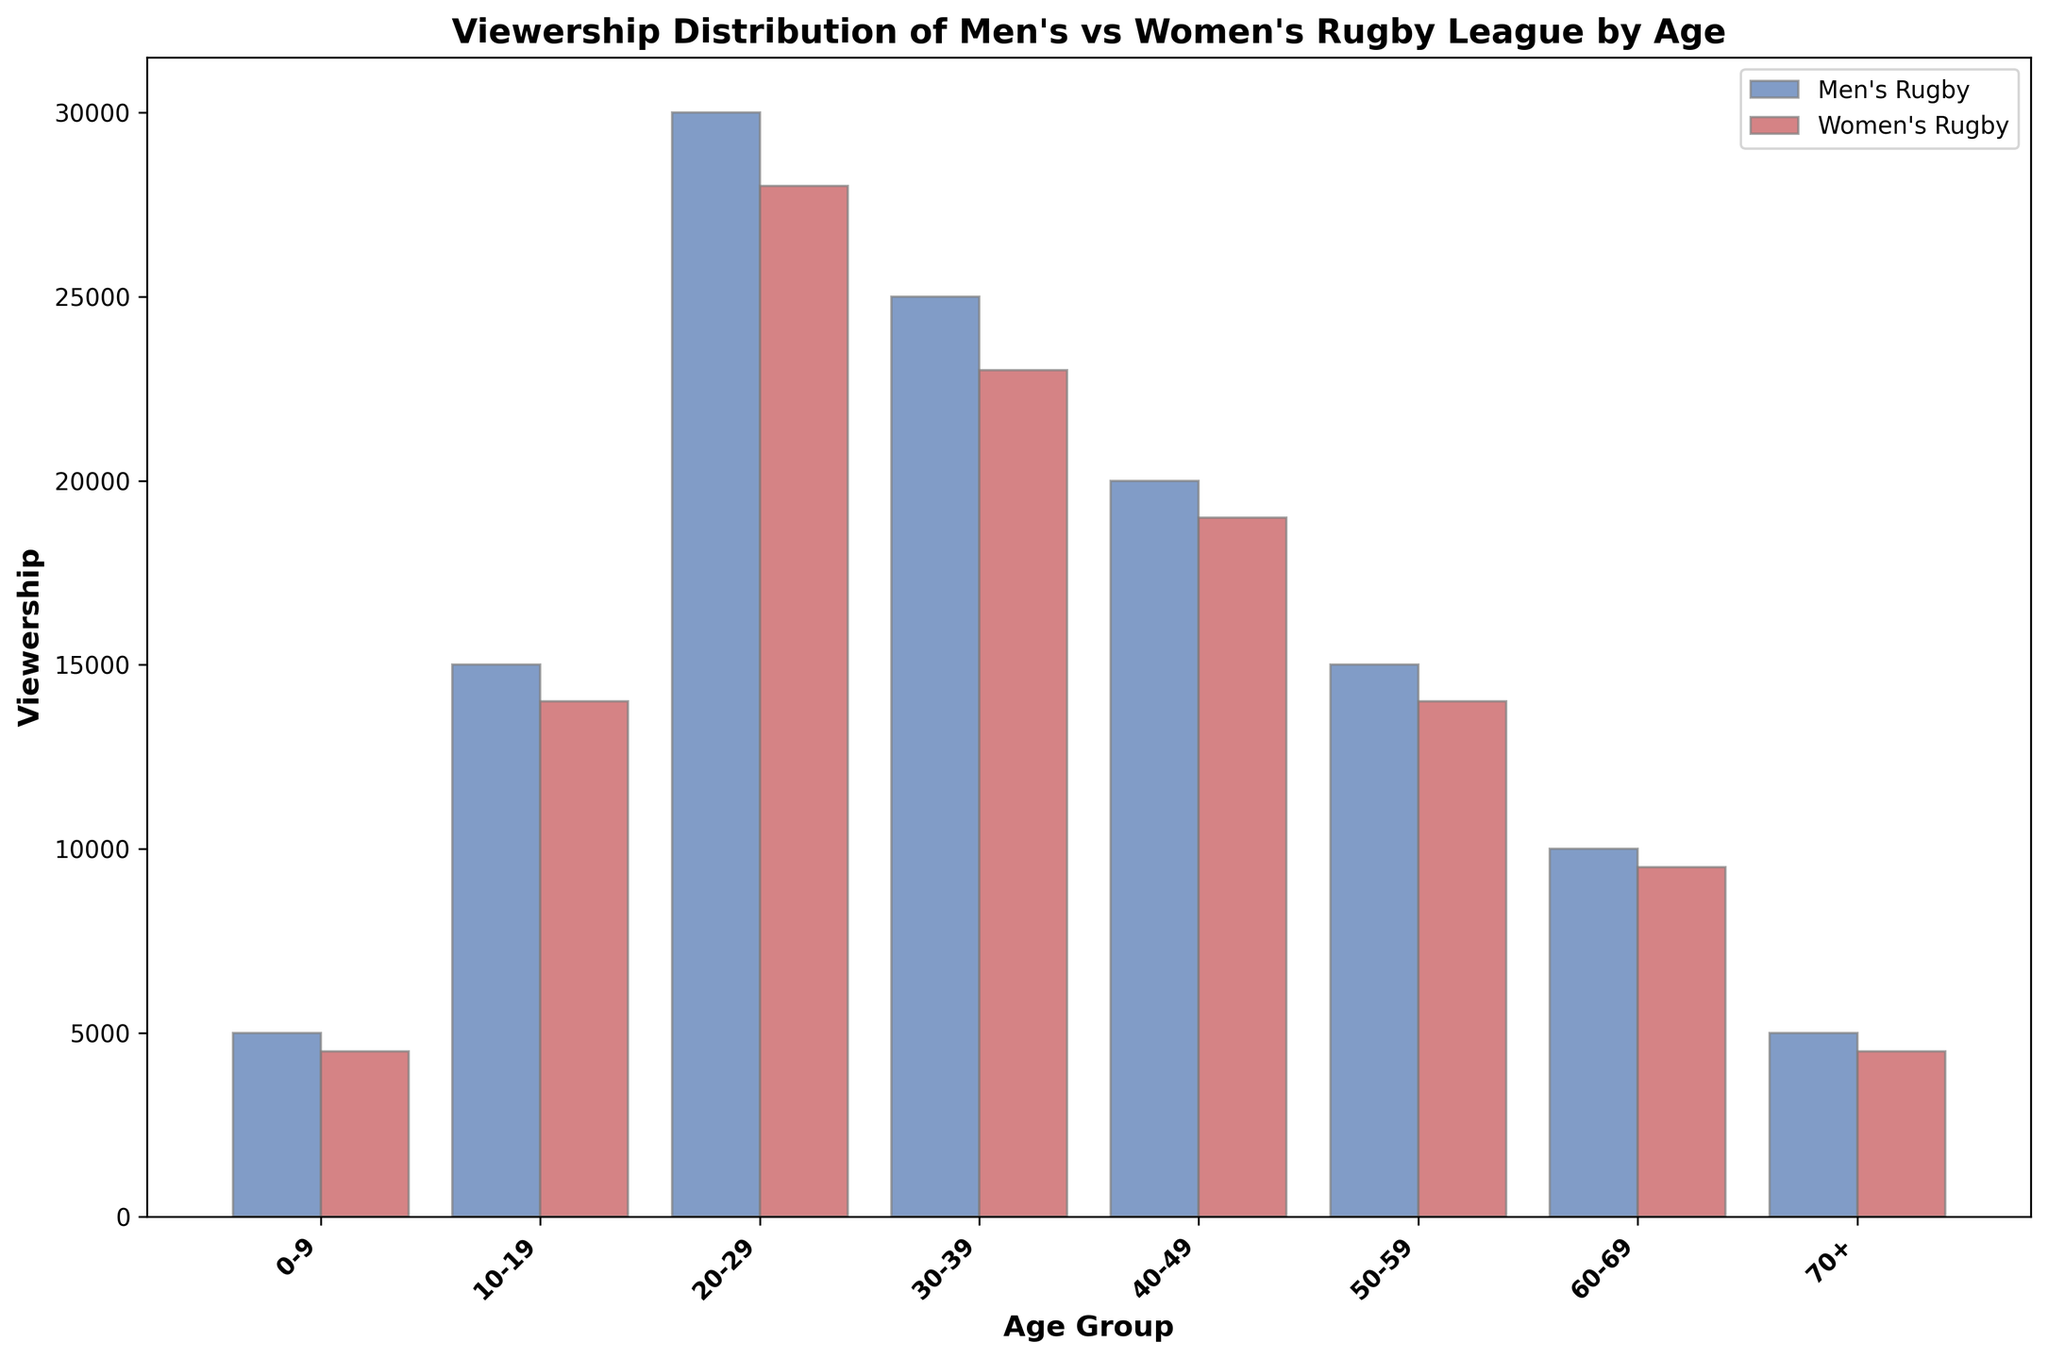What's the age group with the highest viewership for men's rugby league? The age group with the highest bar height for men's rugby league represents the highest viewership. The 20-29 age group has the tallest blue bar.
Answer: 20-29 What's the total viewership of men's rugby league for all age groups combined? Add the viewership numbers for all age groups for men's rugby league: 5000 + 15000 + 30000 + 25000 + 20000 + 15000 + 10000 + 5000 = 125000.
Answer: 125000 By how much does the viewership of women's rugby league in the 50-59 age group differ from the 30-39 age group? Subtract the viewership number of 50-59 from 30-39 for women's rugby league: 23000 - 14000 = 9000.
Answer: 9000 Which age group has a higher viewership for men's rugby league compared to women's, across all age groups? Compare the blue and red bar heights for each age group. All age groups show a higher bar for men's rugby league compared to women's.
Answer: All age groups What is the average viewership for women's rugby league across all age groups? Sum the viewership numbers for women's rugby league and divide by the number of age groups: (4500 + 14000 + 28000 + 23000 + 19000 + 14000 + 9500 + 4500) / 8 = 116000 / 8 = 14500.
Answer: 14500 What's the range of viewership for men's rugby league across all age groups? Identify the maximum and minimum values for men's rugby league viewership. The maximum is 30000 (20-29) and the minimum is 5000 (0-9 and 70+). The range is 30000 - 5000 = 25000.
Answer: 25000 How many age groups have women's rugby league viewership of over 20000? Identify the age groups where the red bar height exceeds 20000. Only the 20-29 and 30-39 age groups meet this criterion.
Answer: 2 